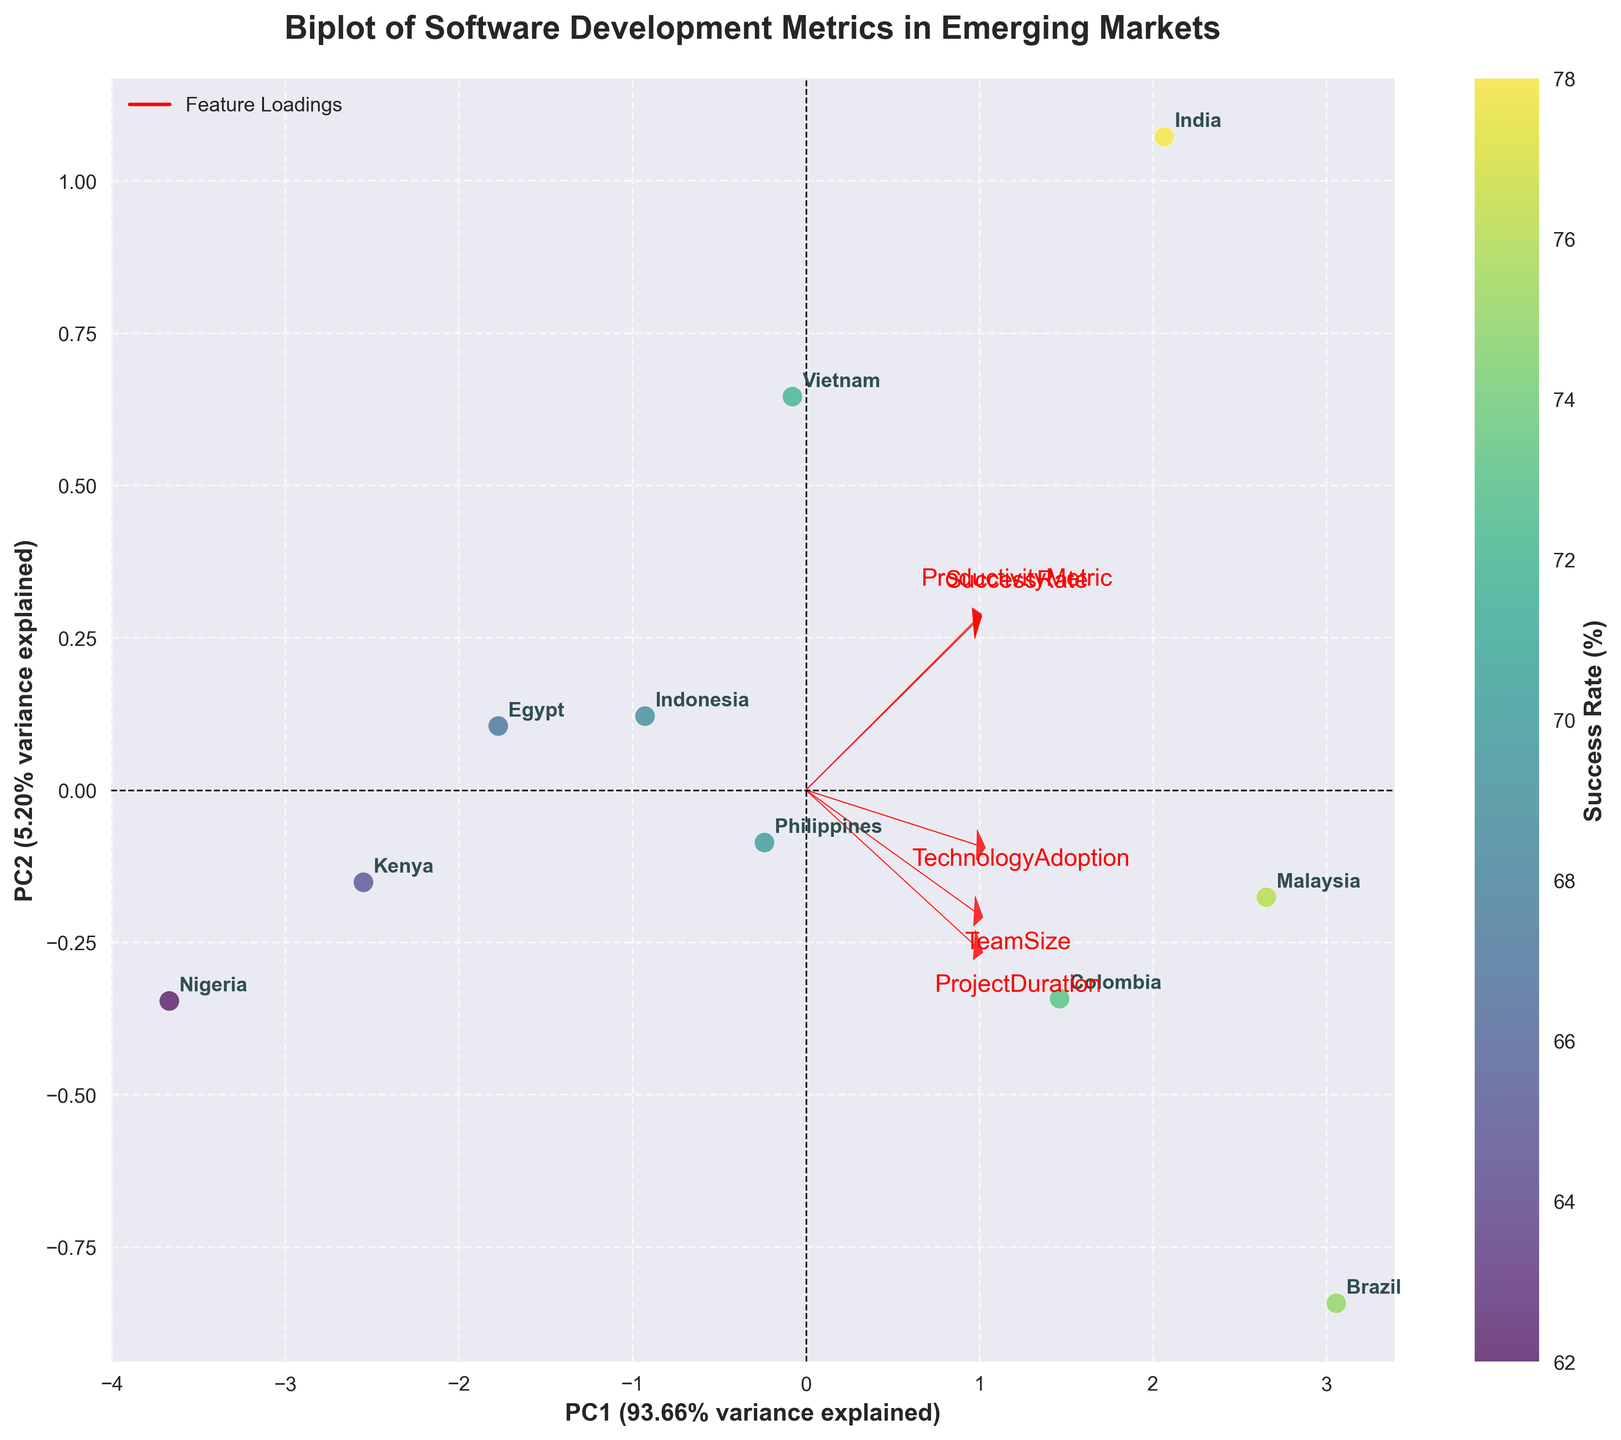What's the title of the biplot? The title can be found at the top of the plot. It should explain what the plot is about. It reads: "Biplot of Software Development Metrics in Emerging Markets."
Answer: Biplot of Software Development Metrics in Emerging Markets Which country has the highest Productivity Metric? Look for the country label closest to the direction of the arrow labeled "ProductivityMetric." This arrow is represented by a red vector pointing towards the coordinates with the highest value on its length. The country closest to it is "India."
Answer: India What do the x and y axes represent? The x and y axes are labeled with the principal components along with their explained variance percentage. The x-axis represents "PC1," which accounts for the largest variance (specified percentage), and the y-axis represents "PC2," which accounts for the second-largest variance (specified percentage).
Answer: PC1 and PC2 with their respective variances Which country has the highest Success Rate? Observe the color gradient (viridis colormap) where countries with higher success rates are mapped in brighter colors. Identify the country label in the brighter region. The country with the highest Success Rate is "India."
Answer: India Does the Philippines's Productivity Metric fall above or below Brazil's? Identify the loadings for "ProductivityMetric" and observe the positions of "Philippines" and "Brazil" concerning that vector. The Philippines is slightly to the left of Brazil along the ProductivityMetric axis. Therefore, the Philippines has a slightly lower Productivity Metric compared to Brazil.
Answer: Below What factors are closely related to Project Duration according to the loadings? Look at the vector representing "ProjectDuration" and see which variables lie closely along this vector. Closely related factors have their arrows pointing in a similar direction. Both "TechnologyAdoption" and "TeamSize" vectors lie in a direction somewhat comparable to "ProjectDuration."
Answer: Technology Adoption and Team Size Which country has the smallest Team Size? Find the direction of the TeamSize vector and identify the country farthest from this vector in the opposite direction. The country closest to the vector's negative side is "Nigeria."
Answer: Nigeria Is Technology Adoption positively correlated with Success Rate? Check the angle between the vectors representing "TechnologyAdoption" and "SuccessRate." A smaller angle (ideally less than 90 degrees) indicates a positive correlation, while a larger angle (greater than 90 degrees) indicates a negative correlation. The angle between these vectors is small, suggesting a positive correlation.
Answer: Yes Which country appears to have the longest Project Duration based on the biplot? The ProjectDuration feature is pointing towards a certain direction. Locate the country that is nearest to the tip of this arrow, which indicates the highest value. The country closest is "Brazil."
Answer: Brazil How many factors are being compared in the biplot? Count the number of arrows (vectors) representing different metrics. Each vector corresponds to a different factor. The factors presented are "ProductivityMetric," "SuccessRate," "TeamSize," "ProjectDuration," and "TechnologyAdoption," leading to a total of five arrows.
Answer: 5 